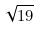Convert formula to latex. <formula><loc_0><loc_0><loc_500><loc_500>\sqrt { 1 9 }</formula> 